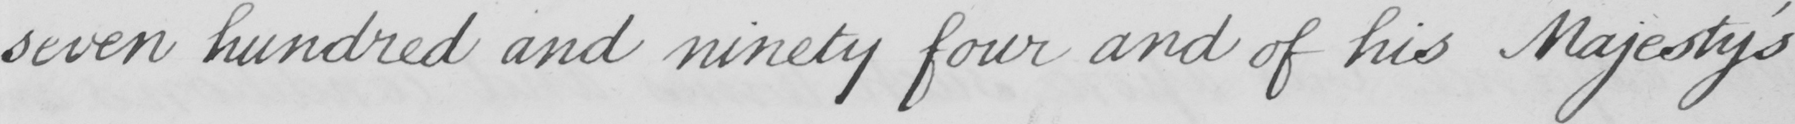Please provide the text content of this handwritten line. seven hundred and ninety four and of his Majesty ' s 